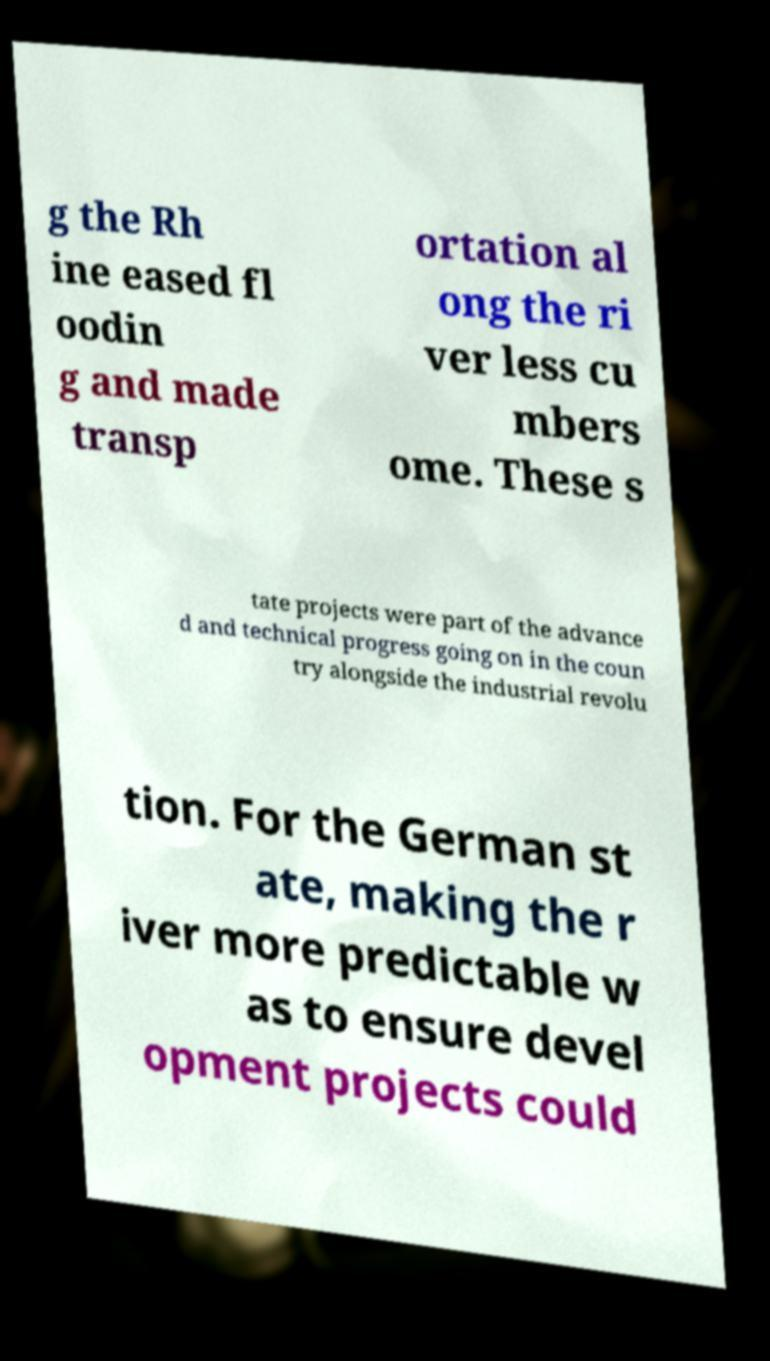Could you assist in decoding the text presented in this image and type it out clearly? g the Rh ine eased fl oodin g and made transp ortation al ong the ri ver less cu mbers ome. These s tate projects were part of the advance d and technical progress going on in the coun try alongside the industrial revolu tion. For the German st ate, making the r iver more predictable w as to ensure devel opment projects could 